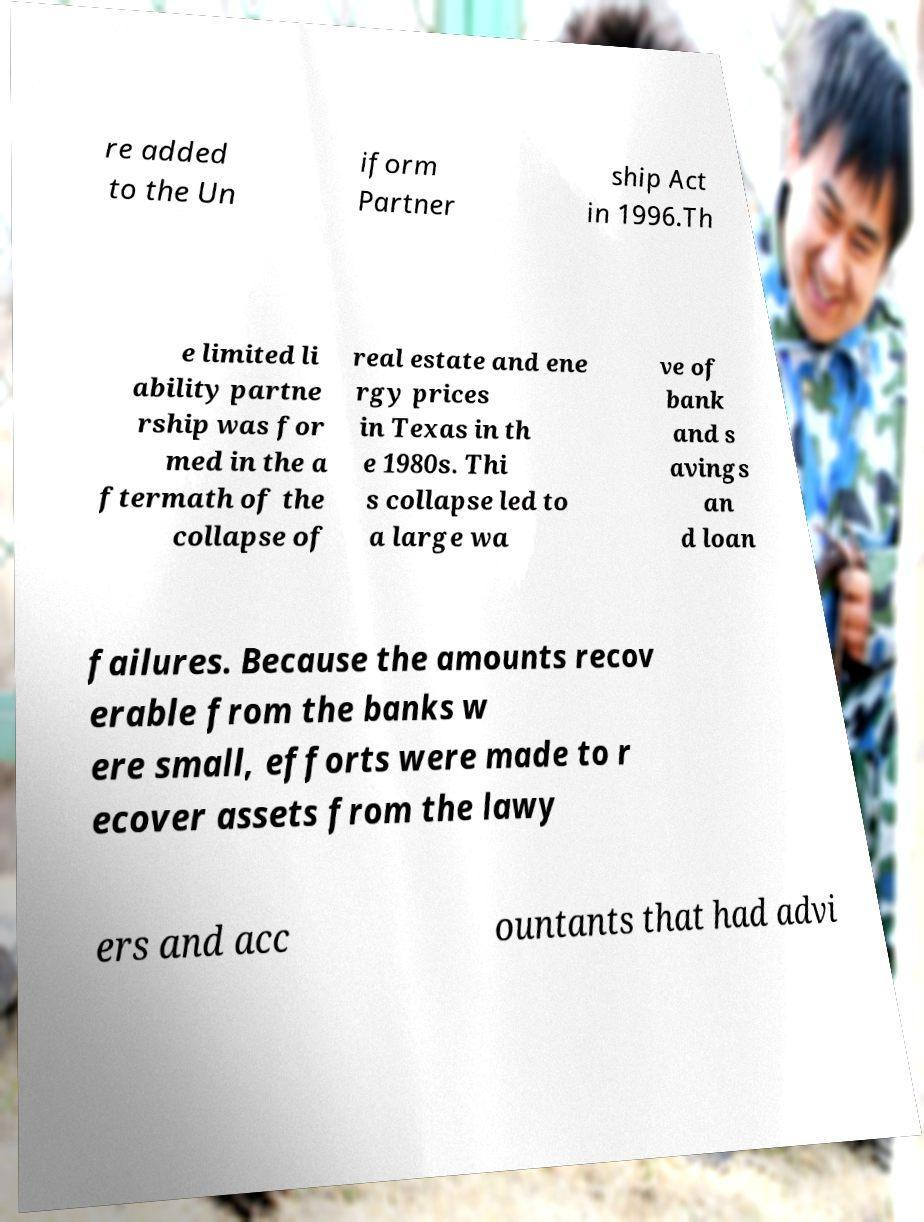Please identify and transcribe the text found in this image. re added to the Un iform Partner ship Act in 1996.Th e limited li ability partne rship was for med in the a ftermath of the collapse of real estate and ene rgy prices in Texas in th e 1980s. Thi s collapse led to a large wa ve of bank and s avings an d loan failures. Because the amounts recov erable from the banks w ere small, efforts were made to r ecover assets from the lawy ers and acc ountants that had advi 